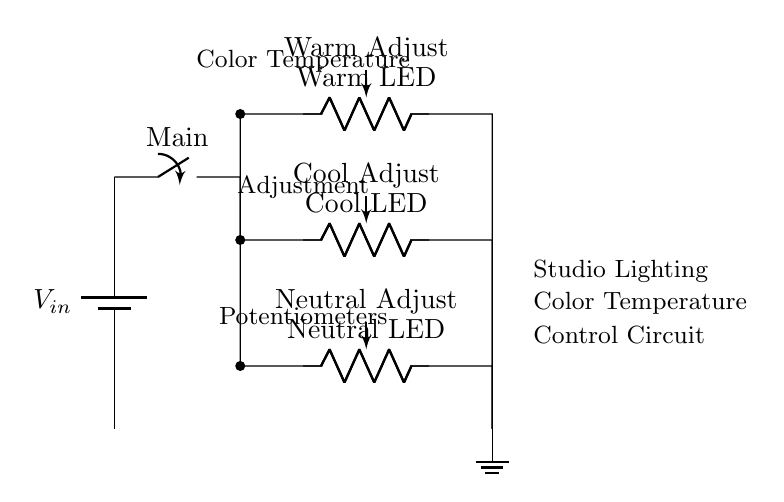What is the power supply component? The circuit diagram features a battery component, specifically noted as V_in, which is the source of electrical power for the circuit.
Answer: Battery What are the types of LEDs used in the circuit? The circuit has three types of LEDs labeled as Warm LED, Cool LED, and Neutral LED, each representing different color temperatures for the studio lighting.
Answer: Warm, Cool, Neutral How many potentiometers are present? There are three potentiometers in the circuit, each corresponding to the different LED types for color temperature adjustment, ensuring tonal control in the lighting system.
Answer: Three What is the function of the switch? The switch labeled Main allows the user to turn the circuit on or off, controlling the flow of electricity from the power supply to the parallel branches of the circuit.
Answer: Control power What is depicted above the color temperature adjustment in the circuit? Above the LEDs, there are labels indicating “Color Temperature,” “Adjustment,” and “Potentiometers,” specifying the role of each component in regulating the lighting tone.
Answer: Color Temperature Which components are in parallel? The Warm LED, Cool LED, and Neutral LED with their respective potentiometers are all connected in parallel to the main switch, allowing each light to operate independently but still be powered by the same input voltage.
Answer: Warm, Cool, Neutral How does adjusting the potentiometer affect the LEDs? Adjusting the potentiometers changes the resistance in each branch of the parallel circuit, thus altering the current flowing to each LED and fine-tuning the overall color temperature of the lighting in the studio.
Answer: Changes color temperature 